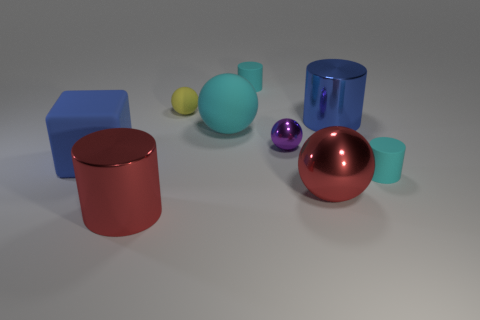There is a tiny purple shiny ball; are there any purple spheres on the right side of it?
Provide a succinct answer. No. What color is the rubber thing that is the same size as the blue block?
Keep it short and to the point. Cyan. How many objects are either cyan cylinders that are on the right side of the big blue metal object or yellow metal spheres?
Keep it short and to the point. 1. How big is the thing that is to the right of the large cyan object and behind the big blue shiny object?
Your answer should be very brief. Small. There is a thing that is the same color as the cube; what is its size?
Keep it short and to the point. Large. How many other objects are the same size as the purple thing?
Offer a terse response. 3. What color is the shiny cylinder that is behind the large red object in front of the large red ball to the right of the small purple metal sphere?
Offer a terse response. Blue. What shape is the rubber object that is to the left of the big cyan matte thing and on the right side of the big blue cube?
Ensure brevity in your answer.  Sphere. How many other things are the same shape as the small metal object?
Offer a terse response. 3. What shape is the tiny cyan rubber object that is behind the cylinder that is to the right of the blue object that is right of the big red cylinder?
Offer a terse response. Cylinder. 